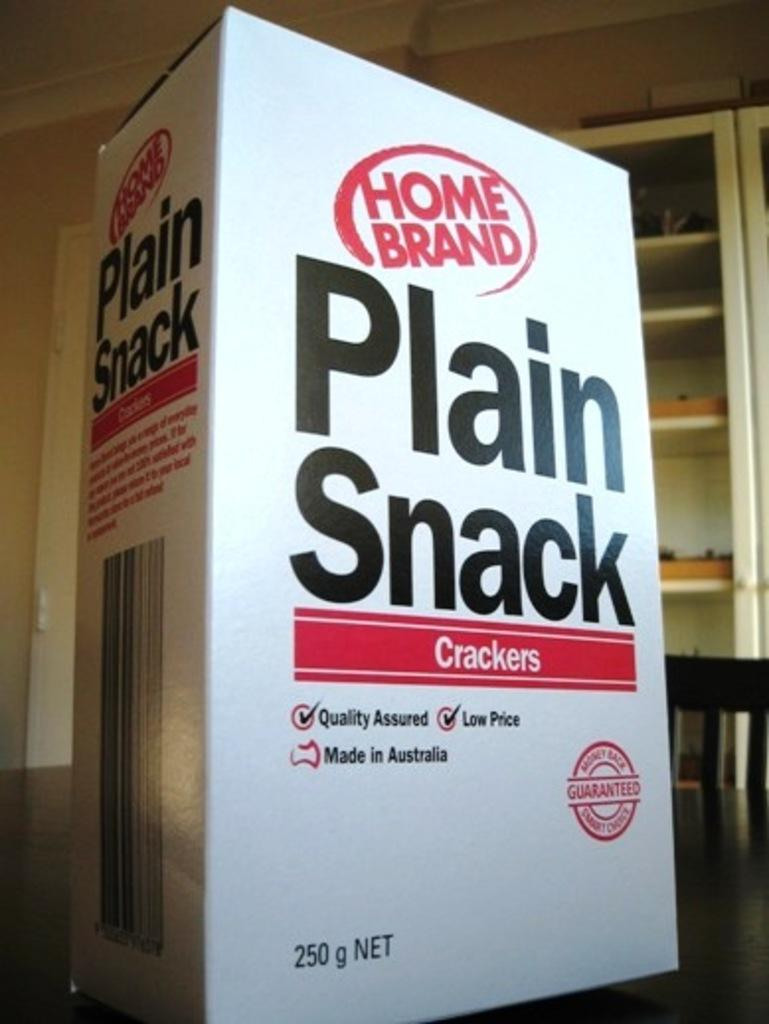<image>
Create a compact narrative representing the image presented. A box of Plain Snack Crackers on a table. 